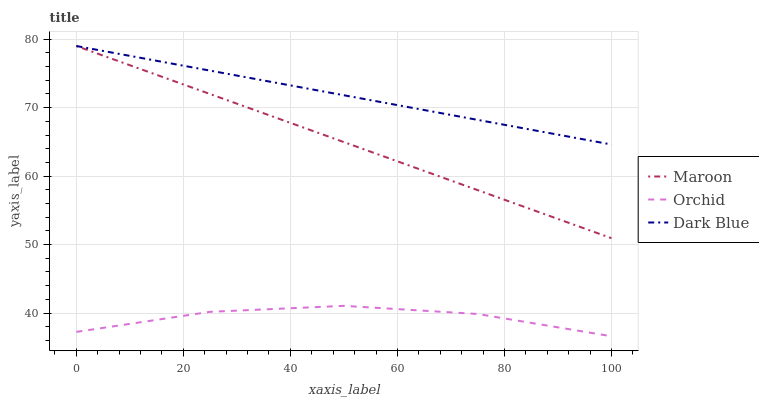Does Orchid have the minimum area under the curve?
Answer yes or no. Yes. Does Dark Blue have the maximum area under the curve?
Answer yes or no. Yes. Does Maroon have the minimum area under the curve?
Answer yes or no. No. Does Maroon have the maximum area under the curve?
Answer yes or no. No. Is Dark Blue the smoothest?
Answer yes or no. Yes. Is Orchid the roughest?
Answer yes or no. Yes. Is Orchid the smoothest?
Answer yes or no. No. Is Maroon the roughest?
Answer yes or no. No. Does Orchid have the lowest value?
Answer yes or no. Yes. Does Maroon have the lowest value?
Answer yes or no. No. Does Maroon have the highest value?
Answer yes or no. Yes. Does Orchid have the highest value?
Answer yes or no. No. Is Orchid less than Maroon?
Answer yes or no. Yes. Is Dark Blue greater than Orchid?
Answer yes or no. Yes. Does Maroon intersect Dark Blue?
Answer yes or no. Yes. Is Maroon less than Dark Blue?
Answer yes or no. No. Is Maroon greater than Dark Blue?
Answer yes or no. No. Does Orchid intersect Maroon?
Answer yes or no. No. 